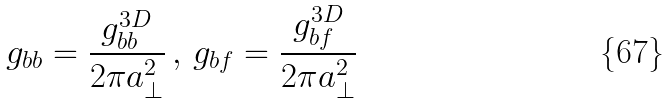<formula> <loc_0><loc_0><loc_500><loc_500>g _ { b b } = \frac { g _ { b b } ^ { 3 D } } { 2 \pi a _ { \perp } ^ { 2 } } \, , \, g _ { b f } = \frac { g _ { b f } ^ { 3 D } } { 2 \pi a _ { \perp } ^ { 2 } }</formula> 